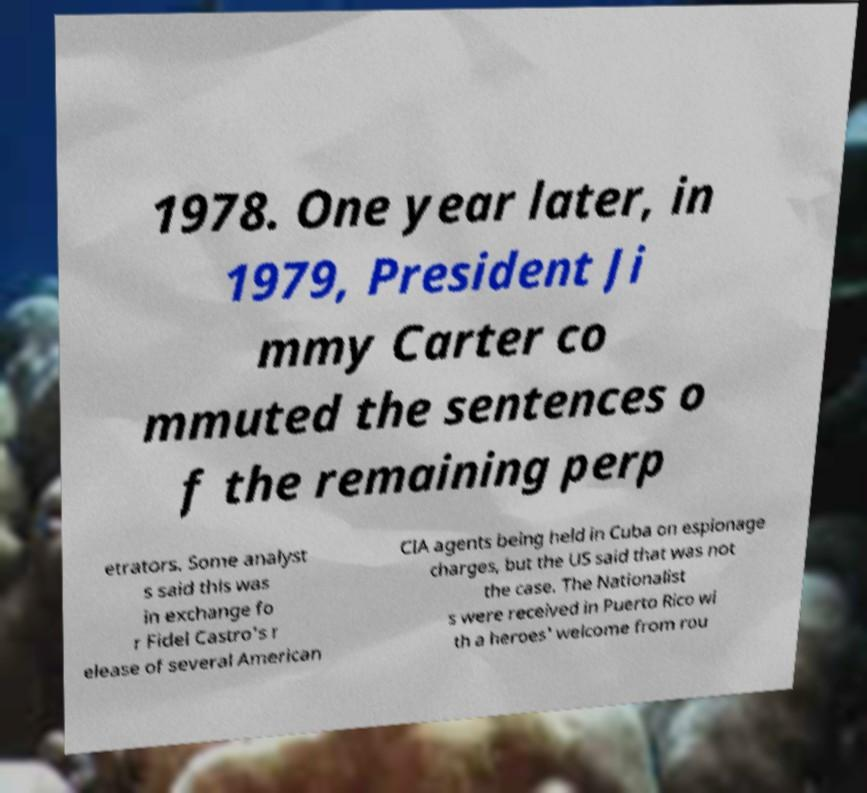Can you accurately transcribe the text from the provided image for me? 1978. One year later, in 1979, President Ji mmy Carter co mmuted the sentences o f the remaining perp etrators. Some analyst s said this was in exchange fo r Fidel Castro's r elease of several American CIA agents being held in Cuba on espionage charges, but the US said that was not the case. The Nationalist s were received in Puerto Rico wi th a heroes' welcome from rou 